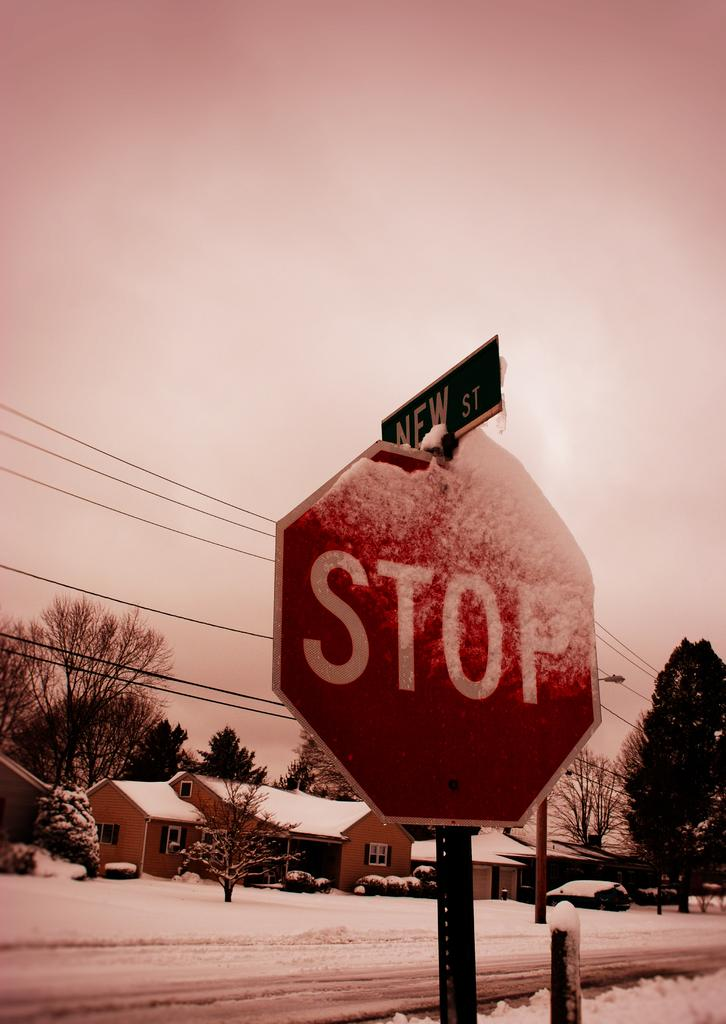<image>
Offer a succinct explanation of the picture presented. A stop sign is partially covered with snow and has a street sign on top of it. 